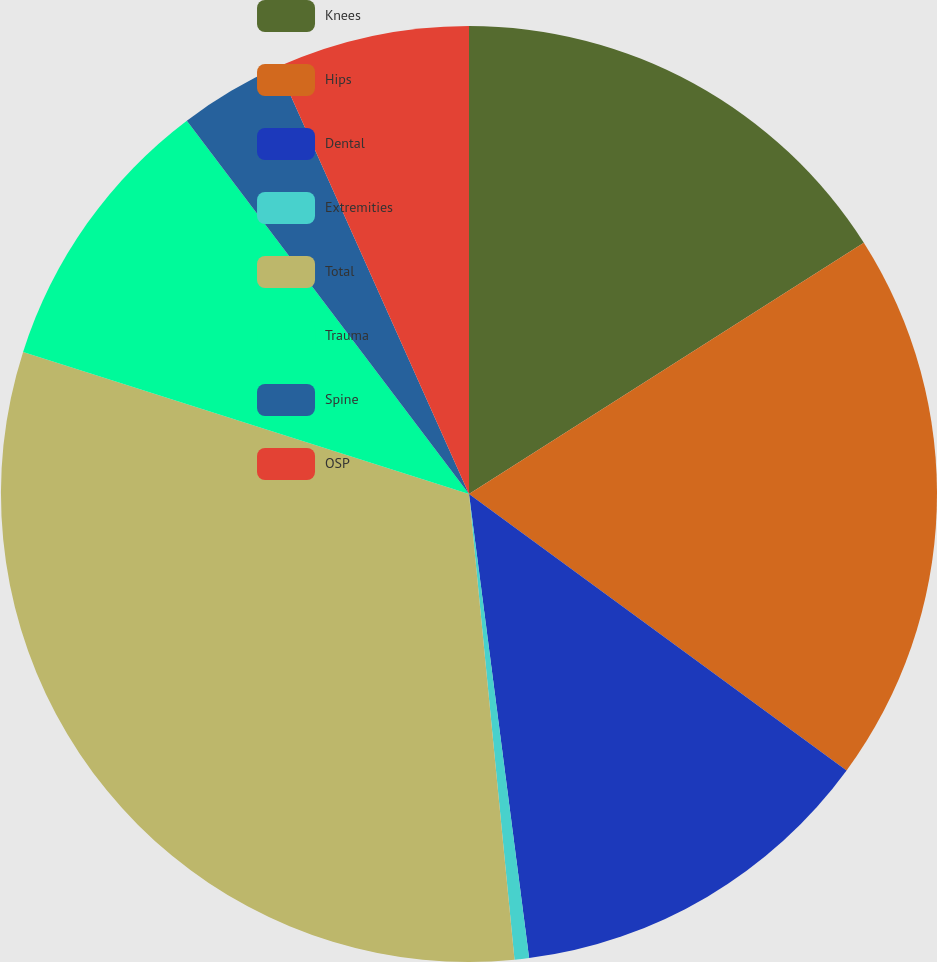Convert chart. <chart><loc_0><loc_0><loc_500><loc_500><pie_chart><fcel>Knees<fcel>Hips<fcel>Dental<fcel>Extremities<fcel>Total<fcel>Trauma<fcel>Spine<fcel>OSP<nl><fcel>15.98%<fcel>19.08%<fcel>12.89%<fcel>0.5%<fcel>31.46%<fcel>9.79%<fcel>3.6%<fcel>6.7%<nl></chart> 